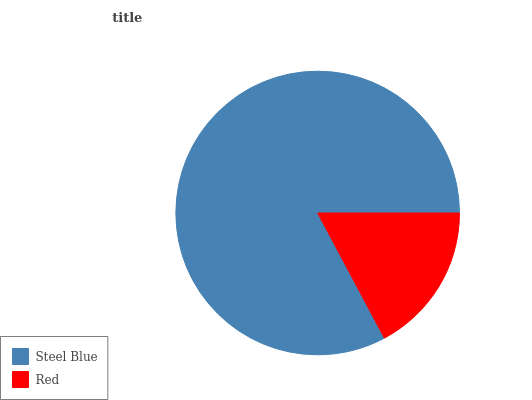Is Red the minimum?
Answer yes or no. Yes. Is Steel Blue the maximum?
Answer yes or no. Yes. Is Red the maximum?
Answer yes or no. No. Is Steel Blue greater than Red?
Answer yes or no. Yes. Is Red less than Steel Blue?
Answer yes or no. Yes. Is Red greater than Steel Blue?
Answer yes or no. No. Is Steel Blue less than Red?
Answer yes or no. No. Is Steel Blue the high median?
Answer yes or no. Yes. Is Red the low median?
Answer yes or no. Yes. Is Red the high median?
Answer yes or no. No. Is Steel Blue the low median?
Answer yes or no. No. 